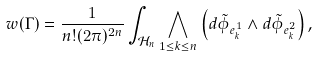Convert formula to latex. <formula><loc_0><loc_0><loc_500><loc_500>w ( \Gamma ) = \frac { 1 } { n ! ( 2 \pi ) ^ { 2 n } } \int _ { \mathcal { H } _ { n } } \bigwedge _ { 1 \leq k \leq n } \left ( d \tilde { \phi } _ { e _ { k } ^ { 1 } } \wedge d \tilde { \phi } _ { e _ { k } ^ { 2 } } \right ) ,</formula> 